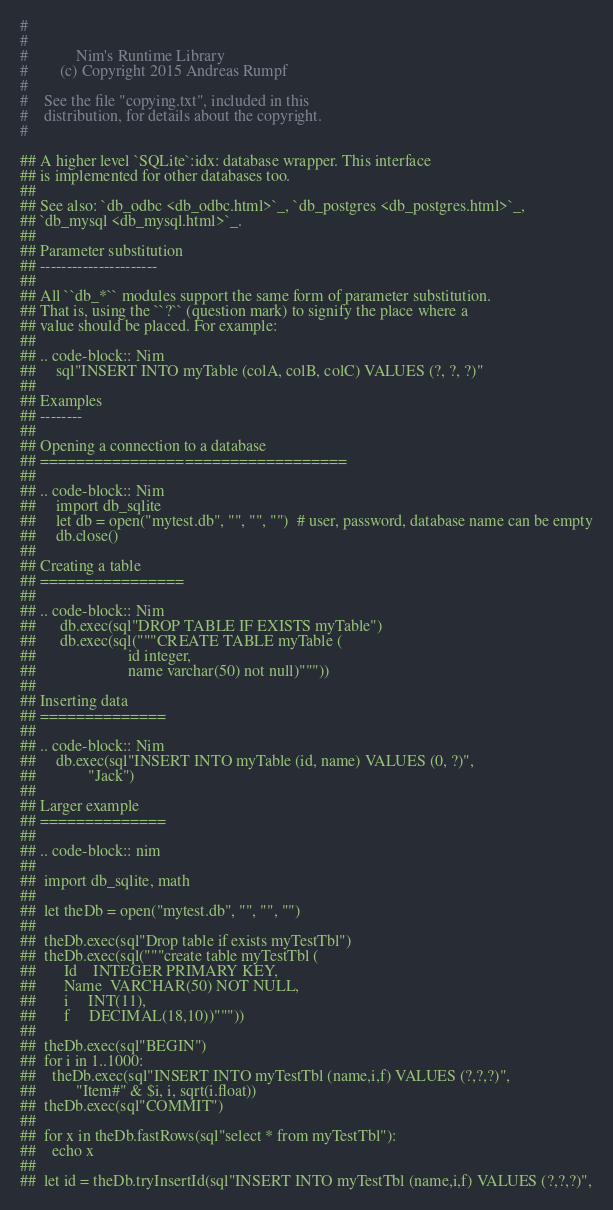Convert code to text. <code><loc_0><loc_0><loc_500><loc_500><_Nim_>#
#
#            Nim's Runtime Library
#        (c) Copyright 2015 Andreas Rumpf
#
#    See the file "copying.txt", included in this
#    distribution, for details about the copyright.
#

## A higher level `SQLite`:idx: database wrapper. This interface
## is implemented for other databases too.
##
## See also: `db_odbc <db_odbc.html>`_, `db_postgres <db_postgres.html>`_,
## `db_mysql <db_mysql.html>`_.
##
## Parameter substitution
## ----------------------
##
## All ``db_*`` modules support the same form of parameter substitution.
## That is, using the ``?`` (question mark) to signify the place where a
## value should be placed. For example:
##
## .. code-block:: Nim
##     sql"INSERT INTO myTable (colA, colB, colC) VALUES (?, ?, ?)"
##
## Examples
## --------
##
## Opening a connection to a database
## ==================================
##
## .. code-block:: Nim
##     import db_sqlite
##     let db = open("mytest.db", "", "", "")  # user, password, database name can be empty
##     db.close()
##
## Creating a table
## ================
##
## .. code-block:: Nim
##      db.exec(sql"DROP TABLE IF EXISTS myTable")
##      db.exec(sql("""CREATE TABLE myTable (
##                       id integer,
##                       name varchar(50) not null)"""))
##
## Inserting data
## ==============
##
## .. code-block:: Nim
##     db.exec(sql"INSERT INTO myTable (id, name) VALUES (0, ?)",
##             "Jack")
##
## Larger example
## ==============
##
## .. code-block:: nim
##
##  import db_sqlite, math
##
##  let theDb = open("mytest.db", "", "", "")
##
##  theDb.exec(sql"Drop table if exists myTestTbl")
##  theDb.exec(sql("""create table myTestTbl (
##       Id    INTEGER PRIMARY KEY,
##       Name  VARCHAR(50) NOT NULL,
##       i     INT(11),
##       f     DECIMAL(18,10))"""))
##
##  theDb.exec(sql"BEGIN")
##  for i in 1..1000:
##    theDb.exec(sql"INSERT INTO myTestTbl (name,i,f) VALUES (?,?,?)",
##          "Item#" & $i, i, sqrt(i.float))
##  theDb.exec(sql"COMMIT")
##
##  for x in theDb.fastRows(sql"select * from myTestTbl"):
##    echo x
##
##  let id = theDb.tryInsertId(sql"INSERT INTO myTestTbl (name,i,f) VALUES (?,?,?)",</code> 